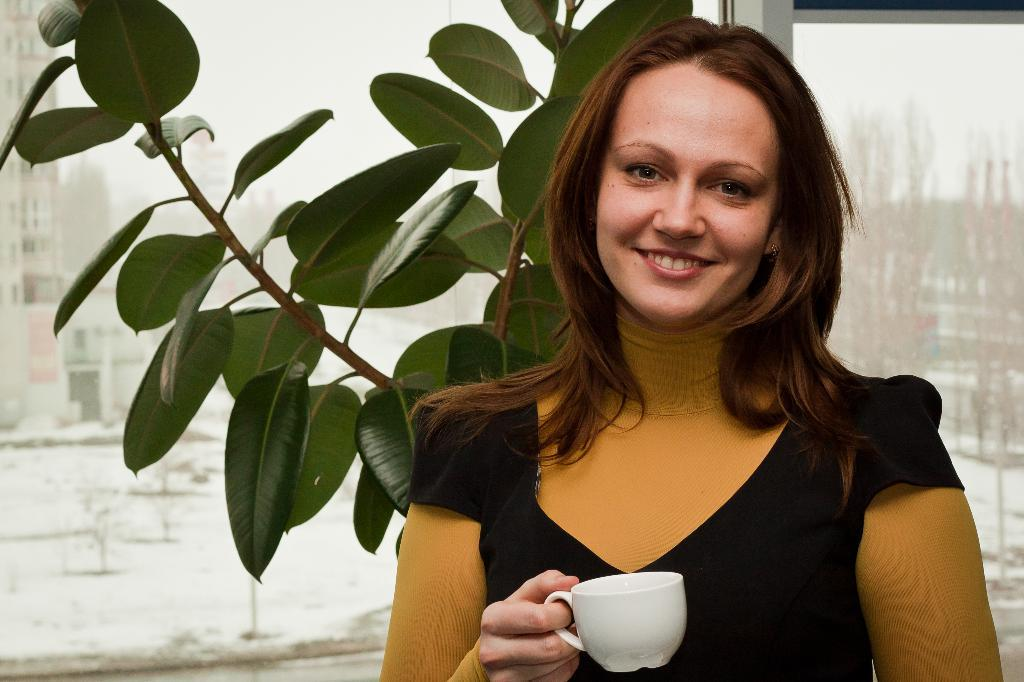Who is present in the image? There is a woman in the image. What is the woman holding in the image? The woman is holding a cup. What is the woman's facial expression in the image? The woman is smiling. What can be seen in the background of the image? There is a plant and a window in the background of the image. What type of rainstorm can be seen through the window in the image? There is no rainstorm visible through the window in the image; it is a clear view of the background. 